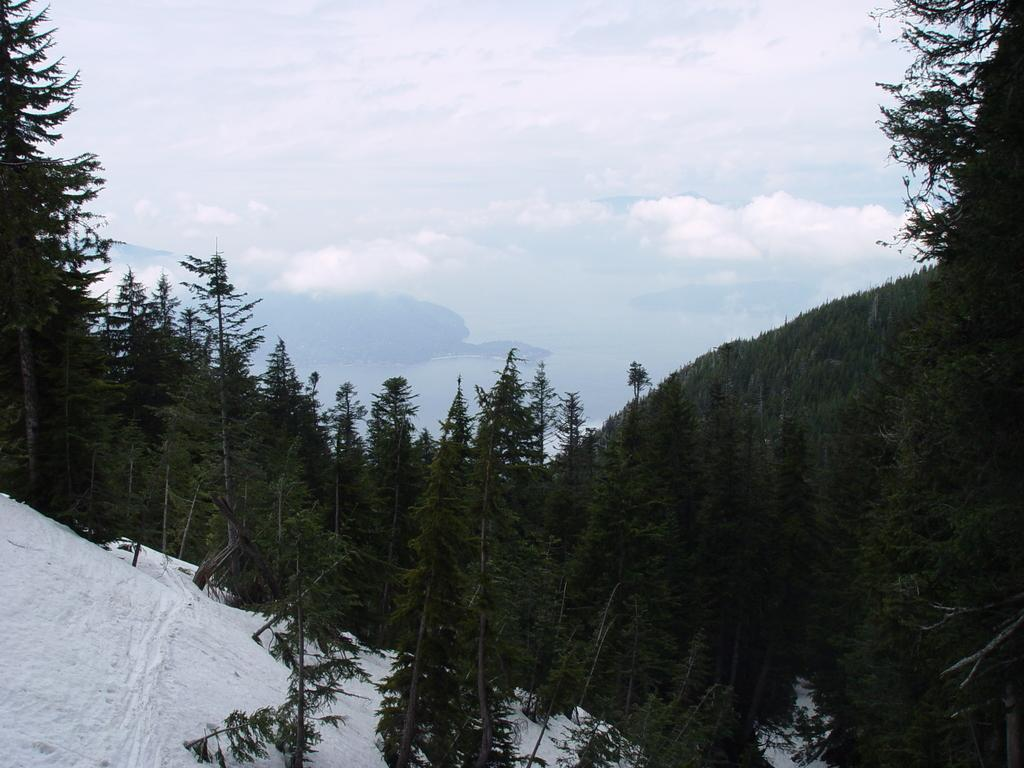What is located in the foreground of the image? There are trees in the foreground of the image. Where are the trees situated? The trees are on mountains. What can be seen in the bottom left corner of the image? There is snow in the left bottom corner of the image. What is visible in the background of the image? The sky is visible in the image. What can be observed in the sky? Clouds are present in the sky. What type of berry can be seen growing on the trees in the image? There are no berries visible on the trees in the image. What is the tin used for in the image? There is no tin present in the image. 